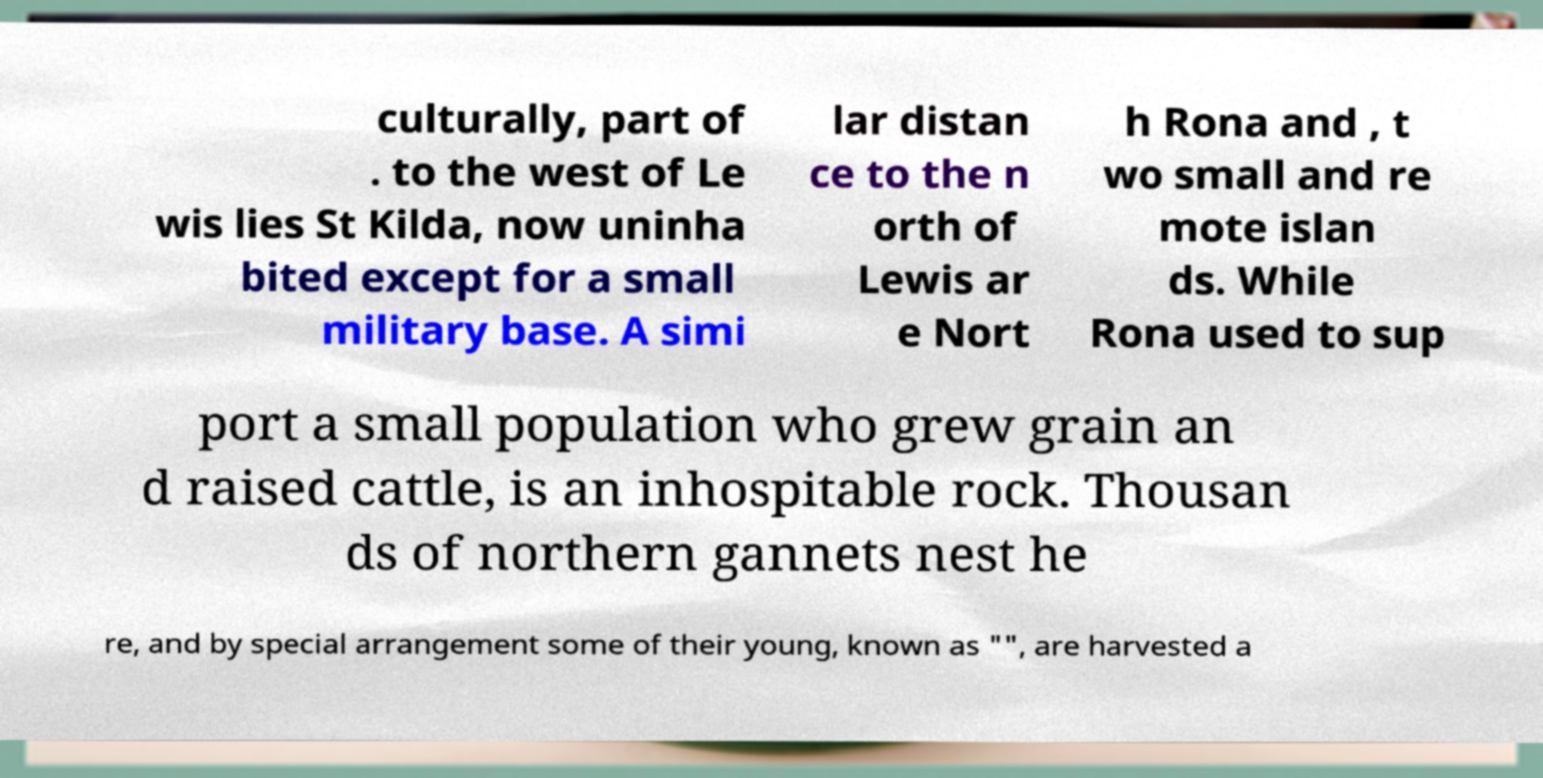Please identify and transcribe the text found in this image. culturally, part of . to the west of Le wis lies St Kilda, now uninha bited except for a small military base. A simi lar distan ce to the n orth of Lewis ar e Nort h Rona and , t wo small and re mote islan ds. While Rona used to sup port a small population who grew grain an d raised cattle, is an inhospitable rock. Thousan ds of northern gannets nest he re, and by special arrangement some of their young, known as "", are harvested a 